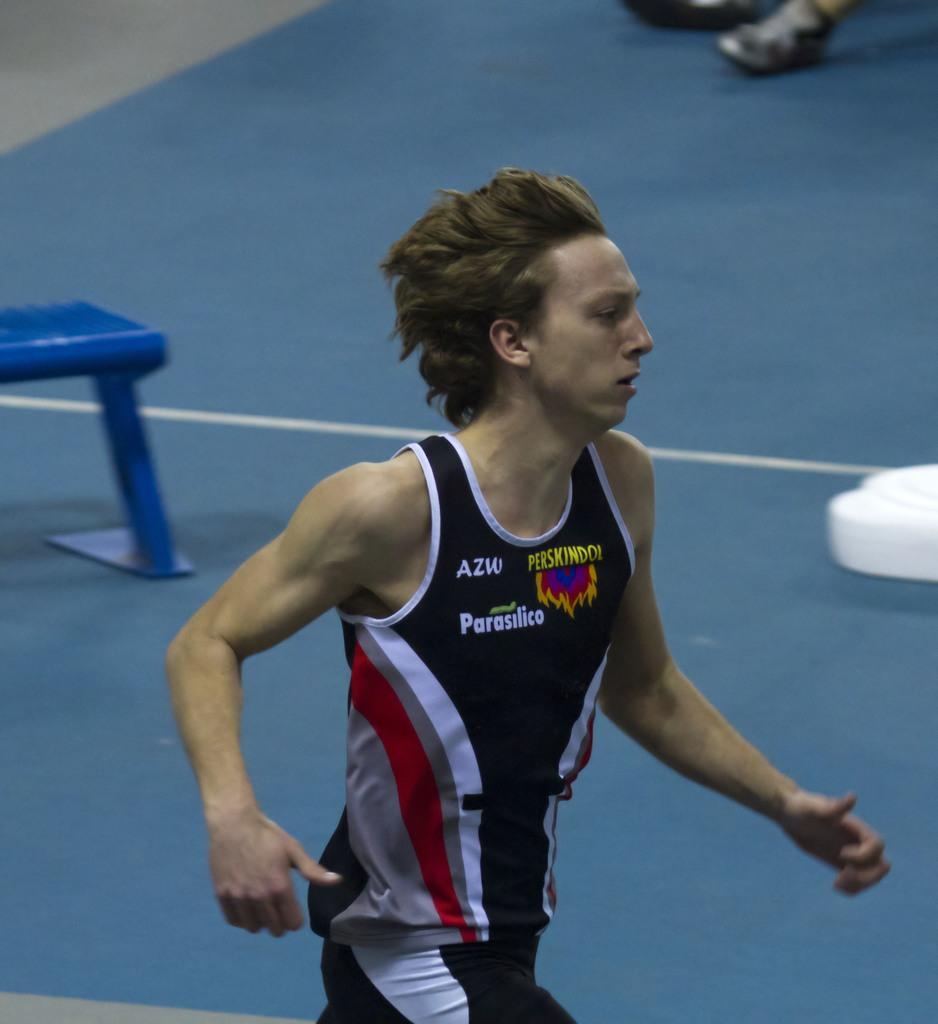<image>
Provide a brief description of the given image. A young man with Parasilico on the front of his shirt runs. 